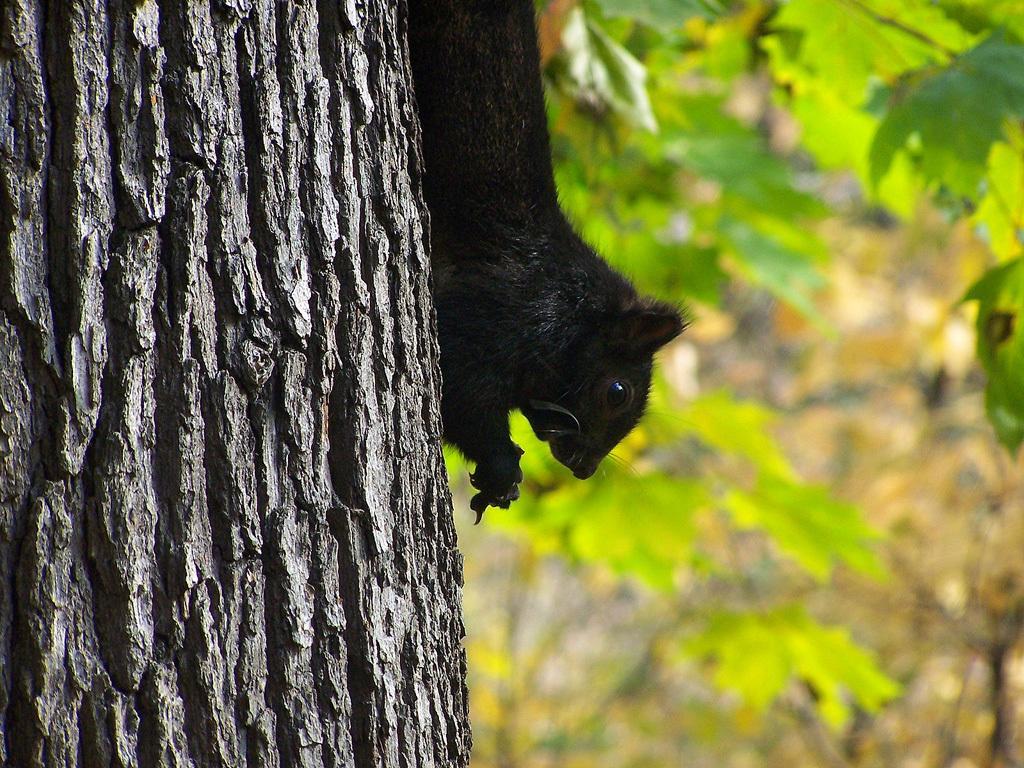How would you summarize this image in a sentence or two? This picture is clicked outside. In the center there is a black color animal seems to be a squirrel on the trunk of a tree. In the background we can see the leaves and some other items. 